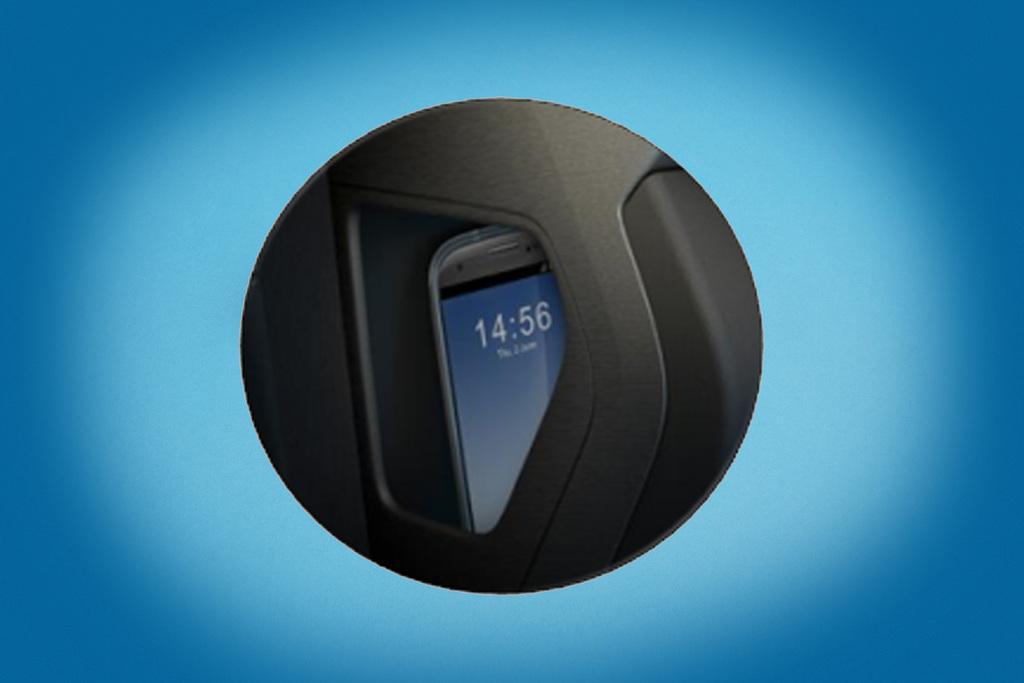What time is on it?
Your response must be concise. 14:56. 